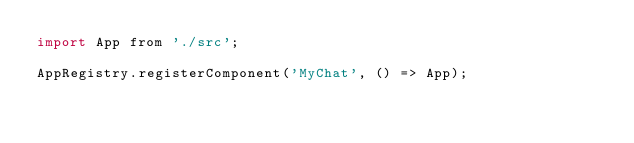Convert code to text. <code><loc_0><loc_0><loc_500><loc_500><_JavaScript_>import App from './src';

AppRegistry.registerComponent('MyChat', () => App);
</code> 